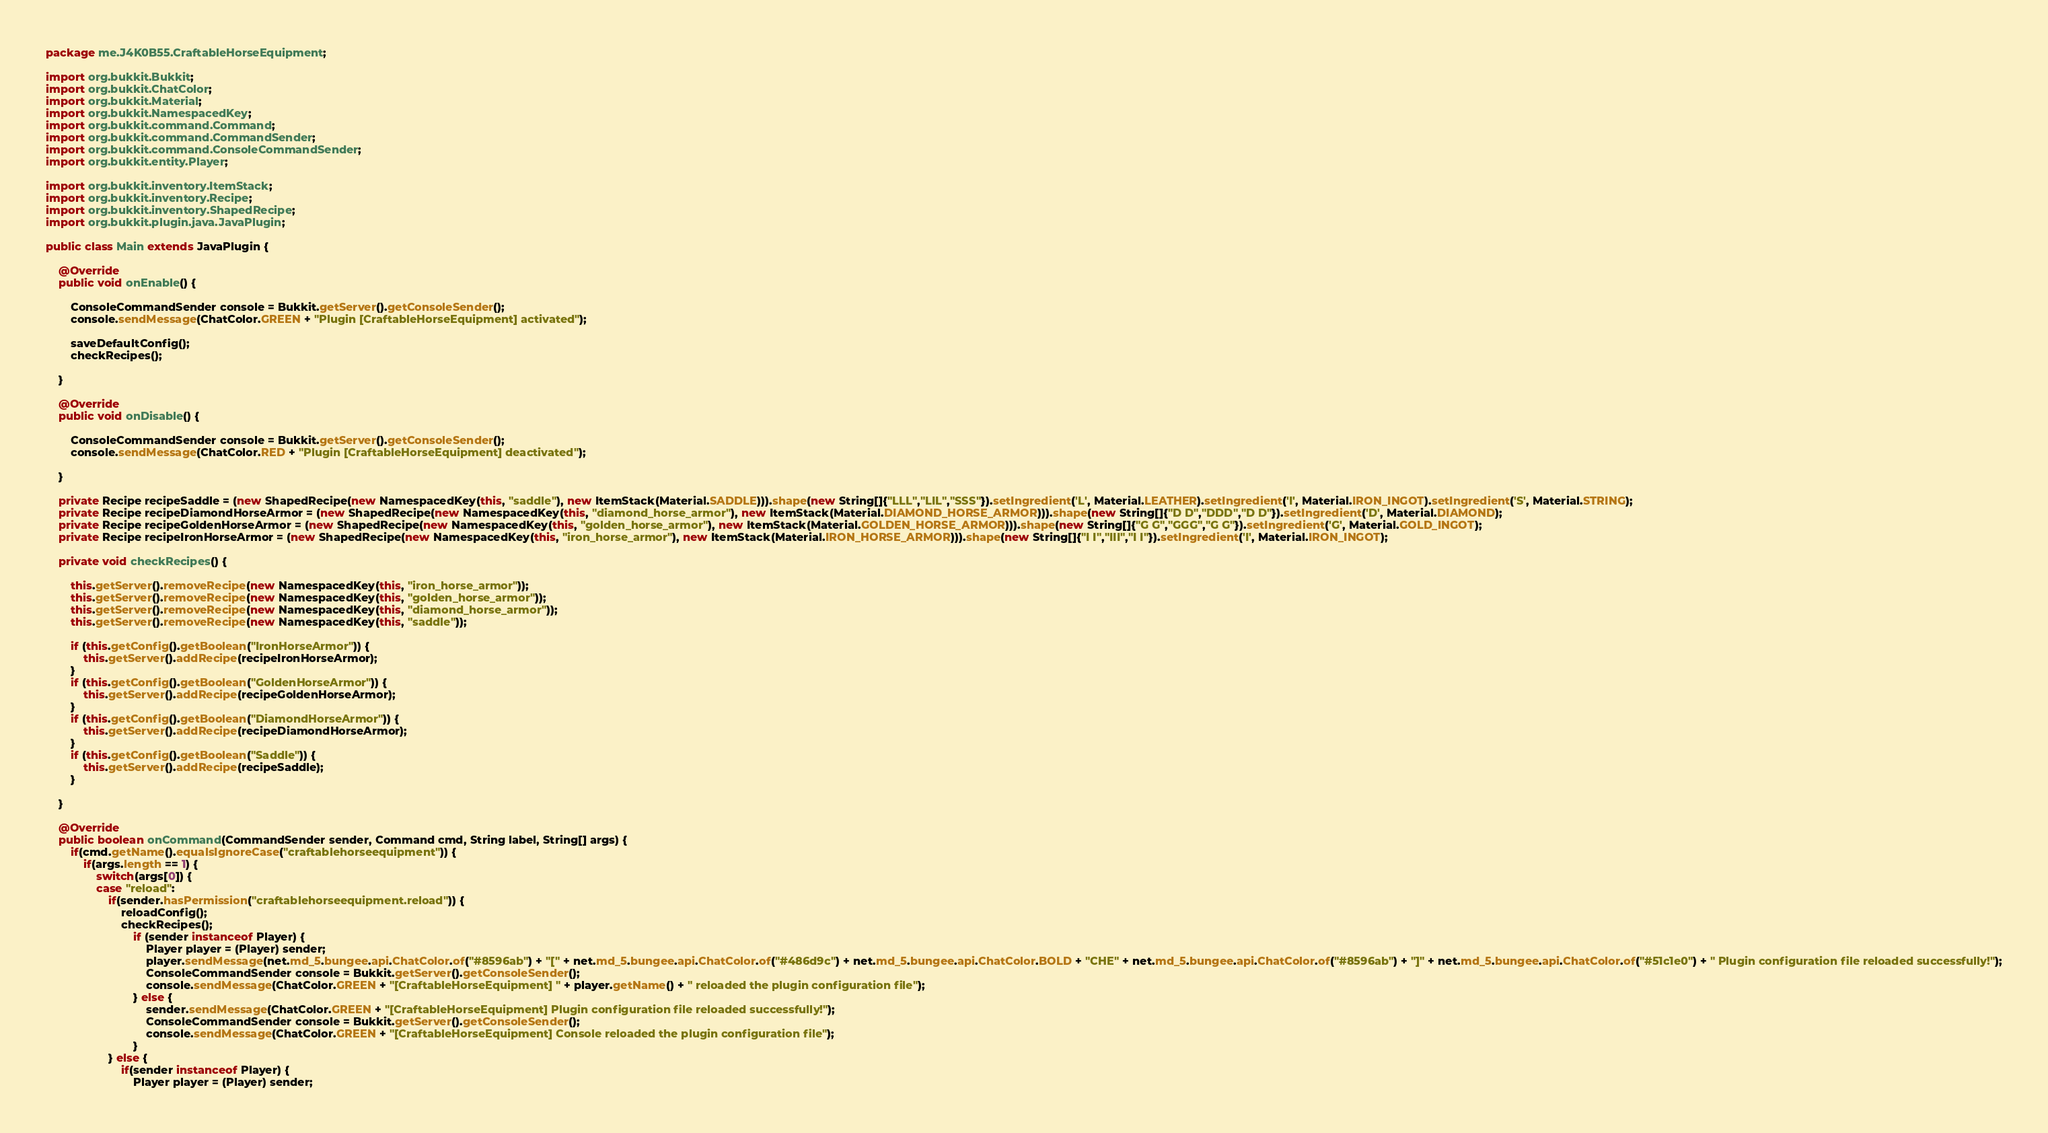Convert code to text. <code><loc_0><loc_0><loc_500><loc_500><_Java_>package me.J4K0B55.CraftableHorseEquipment;

import org.bukkit.Bukkit;
import org.bukkit.ChatColor;
import org.bukkit.Material;
import org.bukkit.NamespacedKey;
import org.bukkit.command.Command;
import org.bukkit.command.CommandSender;
import org.bukkit.command.ConsoleCommandSender;
import org.bukkit.entity.Player;

import org.bukkit.inventory.ItemStack;
import org.bukkit.inventory.Recipe;
import org.bukkit.inventory.ShapedRecipe;
import org.bukkit.plugin.java.JavaPlugin;

public class Main extends JavaPlugin {
	
	@Override
	public void onEnable() {

		ConsoleCommandSender console = Bukkit.getServer().getConsoleSender();
		console.sendMessage(ChatColor.GREEN + "Plugin [CraftableHorseEquipment] activated");
		
		saveDefaultConfig();
		checkRecipes();
		
	}

	@Override
	public void onDisable() {

		ConsoleCommandSender console = Bukkit.getServer().getConsoleSender();
		console.sendMessage(ChatColor.RED + "Plugin [CraftableHorseEquipment] deactivated");
		
	}
	
	private Recipe recipeSaddle = (new ShapedRecipe(new NamespacedKey(this, "saddle"), new ItemStack(Material.SADDLE))).shape(new String[]{"LLL","LIL","SSS"}).setIngredient('L', Material.LEATHER).setIngredient('I', Material.IRON_INGOT).setIngredient('S', Material.STRING);
	private Recipe recipeDiamondHorseArmor = (new ShapedRecipe(new NamespacedKey(this, "diamond_horse_armor"), new ItemStack(Material.DIAMOND_HORSE_ARMOR))).shape(new String[]{"D D","DDD","D D"}).setIngredient('D', Material.DIAMOND);
	private Recipe recipeGoldenHorseArmor = (new ShapedRecipe(new NamespacedKey(this, "golden_horse_armor"), new ItemStack(Material.GOLDEN_HORSE_ARMOR))).shape(new String[]{"G G","GGG","G G"}).setIngredient('G', Material.GOLD_INGOT);
	private Recipe recipeIronHorseArmor = (new ShapedRecipe(new NamespacedKey(this, "iron_horse_armor"), new ItemStack(Material.IRON_HORSE_ARMOR))).shape(new String[]{"I I","III","I I"}).setIngredient('I', Material.IRON_INGOT);
	
	private void checkRecipes() {
		
		this.getServer().removeRecipe(new NamespacedKey(this, "iron_horse_armor"));
		this.getServer().removeRecipe(new NamespacedKey(this, "golden_horse_armor"));
		this.getServer().removeRecipe(new NamespacedKey(this, "diamond_horse_armor"));
		this.getServer().removeRecipe(new NamespacedKey(this, "saddle"));
		
        if (this.getConfig().getBoolean("IronHorseArmor")) {
            this.getServer().addRecipe(recipeIronHorseArmor);
        }
        if (this.getConfig().getBoolean("GoldenHorseArmor")) {
            this.getServer().addRecipe(recipeGoldenHorseArmor);
        }
        if (this.getConfig().getBoolean("DiamondHorseArmor")) {
            this.getServer().addRecipe(recipeDiamondHorseArmor);
        }
        if (this.getConfig().getBoolean("Saddle")) {
            this.getServer().addRecipe(recipeSaddle);
        }

	}

	@Override
	public boolean onCommand(CommandSender sender, Command cmd, String label, String[] args) {
		if(cmd.getName().equalsIgnoreCase("craftablehorseequipment")) {
			if(args.length == 1) {
				switch(args[0]) {
				case "reload":
					if(sender.hasPermission("craftablehorseequipment.reload")) {
						reloadConfig();
						checkRecipes();
					 		if (sender instanceof Player) {
								Player player = (Player) sender;
								player.sendMessage(net.md_5.bungee.api.ChatColor.of("#8596ab") + "[" + net.md_5.bungee.api.ChatColor.of("#486d9c") + net.md_5.bungee.api.ChatColor.BOLD + "CHE" + net.md_5.bungee.api.ChatColor.of("#8596ab") + "]" + net.md_5.bungee.api.ChatColor.of("#51c1e0") + " Plugin configuration file reloaded successfully!");
								ConsoleCommandSender console = Bukkit.getServer().getConsoleSender();
								console.sendMessage(ChatColor.GREEN + "[CraftableHorseEquipment] " + player.getName() + " reloaded the plugin configuration file");
							} else {
								sender.sendMessage(ChatColor.GREEN + "[CraftableHorseEquipment] Plugin configuration file reloaded successfully!");
								ConsoleCommandSender console = Bukkit.getServer().getConsoleSender();
								console.sendMessage(ChatColor.GREEN + "[CraftableHorseEquipment] Console reloaded the plugin configuration file");
							}
					} else {
						if(sender instanceof Player) {
							Player player = (Player) sender;</code> 